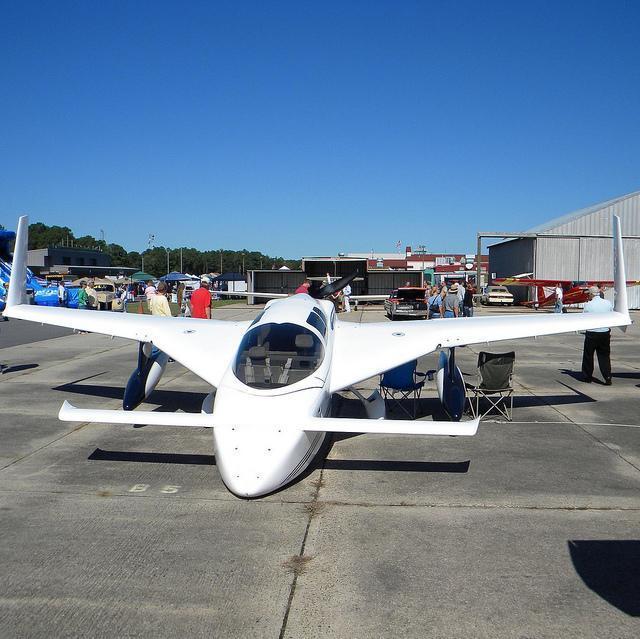How many standing cows are there in the image ?
Give a very brief answer. 0. 